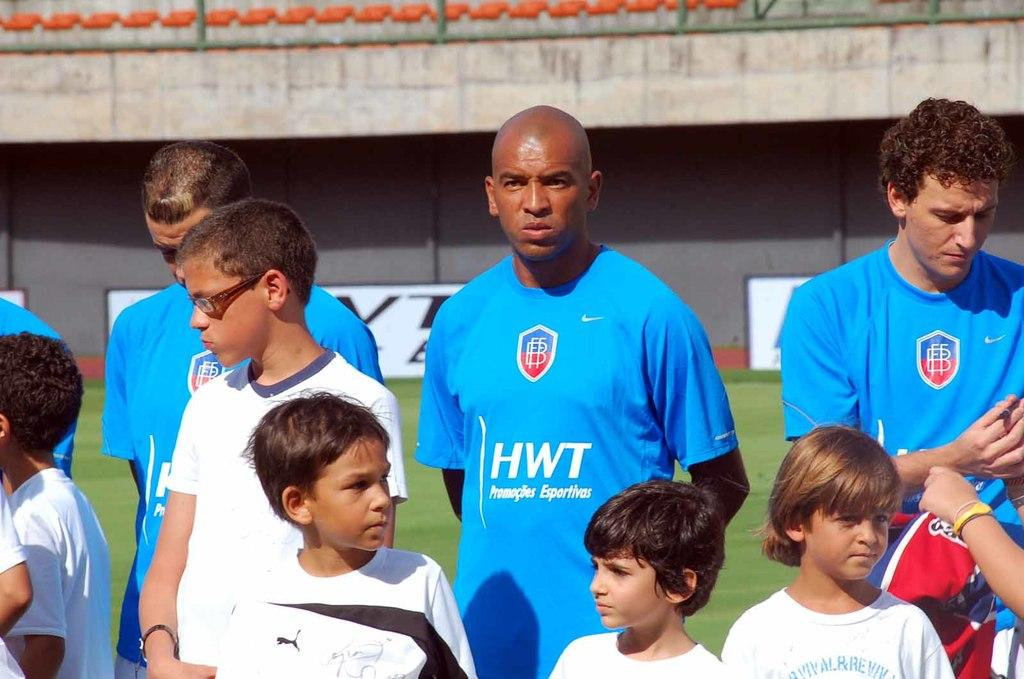<image>
Offer a succinct explanation of the picture presented. A guy in has the letters HWT on his shirt. 